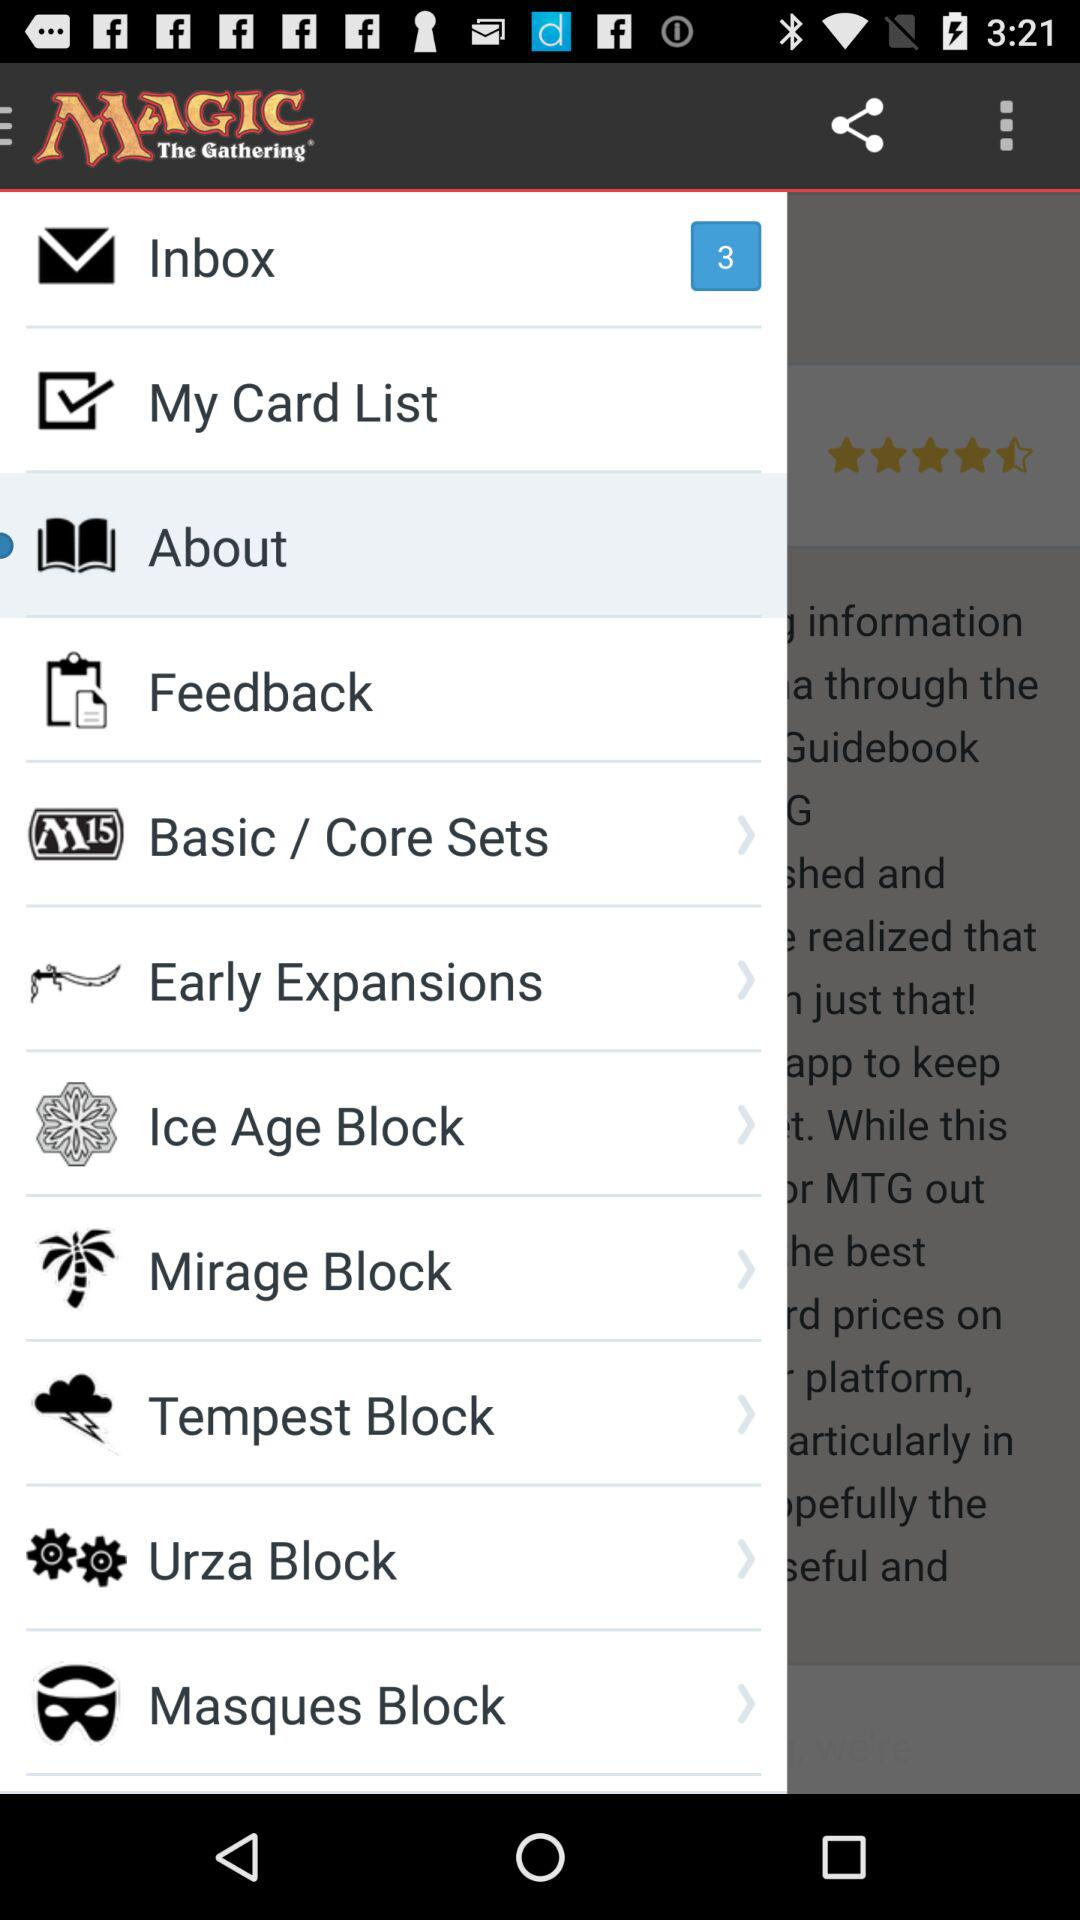How many unread messages are there? There are 3 unread messages. 